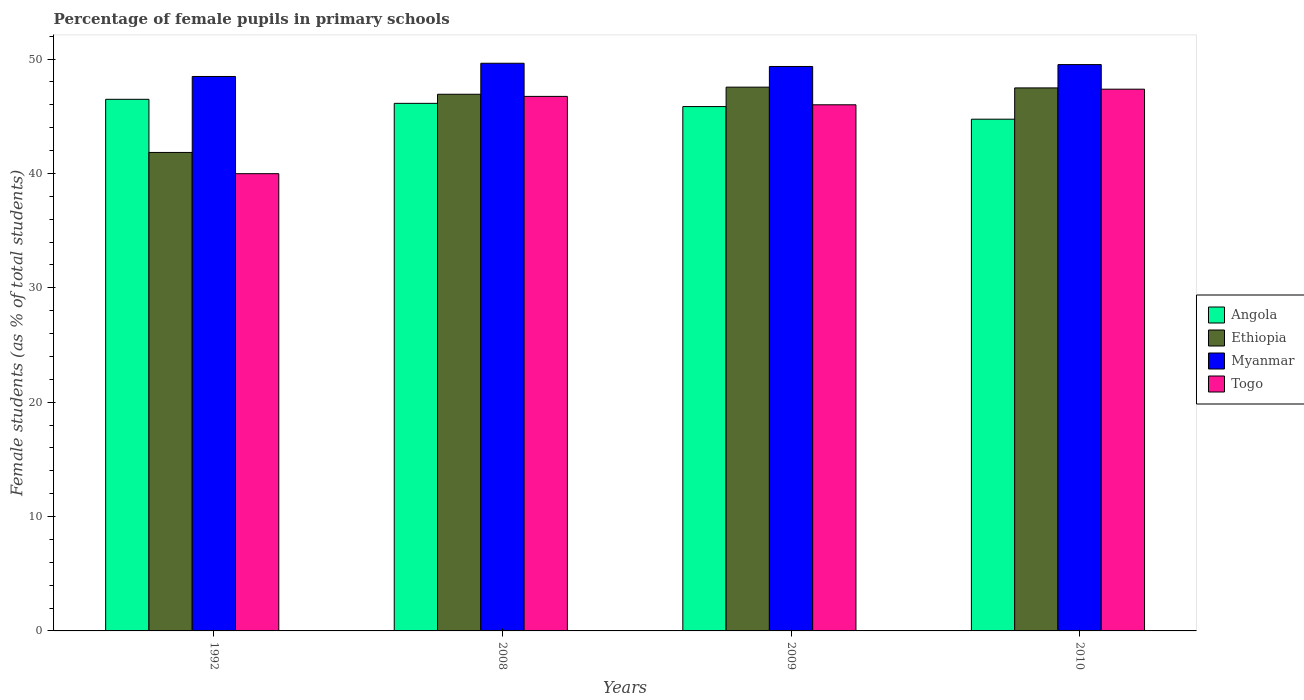What is the percentage of female pupils in primary schools in Ethiopia in 2008?
Offer a very short reply. 46.92. Across all years, what is the maximum percentage of female pupils in primary schools in Angola?
Provide a short and direct response. 46.48. Across all years, what is the minimum percentage of female pupils in primary schools in Myanmar?
Make the answer very short. 48.47. In which year was the percentage of female pupils in primary schools in Myanmar minimum?
Keep it short and to the point. 1992. What is the total percentage of female pupils in primary schools in Ethiopia in the graph?
Your answer should be very brief. 183.76. What is the difference between the percentage of female pupils in primary schools in Togo in 1992 and that in 2009?
Keep it short and to the point. -6.02. What is the difference between the percentage of female pupils in primary schools in Togo in 2010 and the percentage of female pupils in primary schools in Myanmar in 2009?
Keep it short and to the point. -1.98. What is the average percentage of female pupils in primary schools in Togo per year?
Give a very brief answer. 45.02. In the year 1992, what is the difference between the percentage of female pupils in primary schools in Angola and percentage of female pupils in primary schools in Ethiopia?
Your answer should be very brief. 4.65. In how many years, is the percentage of female pupils in primary schools in Ethiopia greater than 26 %?
Your answer should be very brief. 4. What is the ratio of the percentage of female pupils in primary schools in Myanmar in 1992 to that in 2008?
Your answer should be very brief. 0.98. What is the difference between the highest and the second highest percentage of female pupils in primary schools in Ethiopia?
Your response must be concise. 0.07. What is the difference between the highest and the lowest percentage of female pupils in primary schools in Myanmar?
Provide a short and direct response. 1.16. Is the sum of the percentage of female pupils in primary schools in Ethiopia in 2009 and 2010 greater than the maximum percentage of female pupils in primary schools in Myanmar across all years?
Keep it short and to the point. Yes. What does the 4th bar from the left in 1992 represents?
Your response must be concise. Togo. What does the 1st bar from the right in 2009 represents?
Provide a short and direct response. Togo. Is it the case that in every year, the sum of the percentage of female pupils in primary schools in Togo and percentage of female pupils in primary schools in Myanmar is greater than the percentage of female pupils in primary schools in Ethiopia?
Keep it short and to the point. Yes. What is the difference between two consecutive major ticks on the Y-axis?
Provide a short and direct response. 10. Where does the legend appear in the graph?
Keep it short and to the point. Center right. How many legend labels are there?
Ensure brevity in your answer.  4. What is the title of the graph?
Give a very brief answer. Percentage of female pupils in primary schools. Does "East Asia (all income levels)" appear as one of the legend labels in the graph?
Provide a short and direct response. No. What is the label or title of the Y-axis?
Provide a succinct answer. Female students (as % of total students). What is the Female students (as % of total students) in Angola in 1992?
Keep it short and to the point. 46.48. What is the Female students (as % of total students) in Ethiopia in 1992?
Offer a very short reply. 41.83. What is the Female students (as % of total students) in Myanmar in 1992?
Offer a terse response. 48.47. What is the Female students (as % of total students) in Togo in 1992?
Provide a short and direct response. 39.97. What is the Female students (as % of total students) of Angola in 2008?
Offer a very short reply. 46.12. What is the Female students (as % of total students) of Ethiopia in 2008?
Offer a very short reply. 46.92. What is the Female students (as % of total students) of Myanmar in 2008?
Keep it short and to the point. 49.63. What is the Female students (as % of total students) of Togo in 2008?
Provide a short and direct response. 46.73. What is the Female students (as % of total students) of Angola in 2009?
Your answer should be very brief. 45.84. What is the Female students (as % of total students) of Ethiopia in 2009?
Your answer should be compact. 47.54. What is the Female students (as % of total students) of Myanmar in 2009?
Your answer should be very brief. 49.35. What is the Female students (as % of total students) of Togo in 2009?
Offer a very short reply. 46. What is the Female students (as % of total students) in Angola in 2010?
Make the answer very short. 44.74. What is the Female students (as % of total students) of Ethiopia in 2010?
Your answer should be compact. 47.47. What is the Female students (as % of total students) in Myanmar in 2010?
Offer a very short reply. 49.51. What is the Female students (as % of total students) of Togo in 2010?
Provide a succinct answer. 47.36. Across all years, what is the maximum Female students (as % of total students) in Angola?
Provide a succinct answer. 46.48. Across all years, what is the maximum Female students (as % of total students) of Ethiopia?
Offer a very short reply. 47.54. Across all years, what is the maximum Female students (as % of total students) of Myanmar?
Your answer should be very brief. 49.63. Across all years, what is the maximum Female students (as % of total students) of Togo?
Give a very brief answer. 47.36. Across all years, what is the minimum Female students (as % of total students) in Angola?
Ensure brevity in your answer.  44.74. Across all years, what is the minimum Female students (as % of total students) in Ethiopia?
Provide a succinct answer. 41.83. Across all years, what is the minimum Female students (as % of total students) of Myanmar?
Ensure brevity in your answer.  48.47. Across all years, what is the minimum Female students (as % of total students) of Togo?
Your answer should be compact. 39.97. What is the total Female students (as % of total students) in Angola in the graph?
Offer a very short reply. 183.18. What is the total Female students (as % of total students) in Ethiopia in the graph?
Provide a short and direct response. 183.76. What is the total Female students (as % of total students) in Myanmar in the graph?
Your response must be concise. 196.96. What is the total Female students (as % of total students) of Togo in the graph?
Your answer should be very brief. 180.07. What is the difference between the Female students (as % of total students) of Angola in 1992 and that in 2008?
Keep it short and to the point. 0.35. What is the difference between the Female students (as % of total students) of Ethiopia in 1992 and that in 2008?
Provide a short and direct response. -5.09. What is the difference between the Female students (as % of total students) in Myanmar in 1992 and that in 2008?
Your answer should be compact. -1.16. What is the difference between the Female students (as % of total students) of Togo in 1992 and that in 2008?
Offer a very short reply. -6.76. What is the difference between the Female students (as % of total students) of Angola in 1992 and that in 2009?
Ensure brevity in your answer.  0.63. What is the difference between the Female students (as % of total students) in Ethiopia in 1992 and that in 2009?
Provide a short and direct response. -5.71. What is the difference between the Female students (as % of total students) in Myanmar in 1992 and that in 2009?
Provide a short and direct response. -0.87. What is the difference between the Female students (as % of total students) of Togo in 1992 and that in 2009?
Your answer should be compact. -6.02. What is the difference between the Female students (as % of total students) in Angola in 1992 and that in 2010?
Give a very brief answer. 1.74. What is the difference between the Female students (as % of total students) in Ethiopia in 1992 and that in 2010?
Make the answer very short. -5.64. What is the difference between the Female students (as % of total students) of Myanmar in 1992 and that in 2010?
Make the answer very short. -1.04. What is the difference between the Female students (as % of total students) of Togo in 1992 and that in 2010?
Offer a very short reply. -7.39. What is the difference between the Female students (as % of total students) of Angola in 2008 and that in 2009?
Make the answer very short. 0.28. What is the difference between the Female students (as % of total students) of Ethiopia in 2008 and that in 2009?
Keep it short and to the point. -0.62. What is the difference between the Female students (as % of total students) in Myanmar in 2008 and that in 2009?
Keep it short and to the point. 0.28. What is the difference between the Female students (as % of total students) of Togo in 2008 and that in 2009?
Keep it short and to the point. 0.73. What is the difference between the Female students (as % of total students) in Angola in 2008 and that in 2010?
Make the answer very short. 1.39. What is the difference between the Female students (as % of total students) of Ethiopia in 2008 and that in 2010?
Provide a short and direct response. -0.55. What is the difference between the Female students (as % of total students) in Myanmar in 2008 and that in 2010?
Offer a terse response. 0.12. What is the difference between the Female students (as % of total students) in Togo in 2008 and that in 2010?
Offer a very short reply. -0.63. What is the difference between the Female students (as % of total students) in Angola in 2009 and that in 2010?
Provide a succinct answer. 1.1. What is the difference between the Female students (as % of total students) in Ethiopia in 2009 and that in 2010?
Provide a succinct answer. 0.07. What is the difference between the Female students (as % of total students) of Myanmar in 2009 and that in 2010?
Provide a succinct answer. -0.17. What is the difference between the Female students (as % of total students) of Togo in 2009 and that in 2010?
Offer a terse response. -1.36. What is the difference between the Female students (as % of total students) of Angola in 1992 and the Female students (as % of total students) of Ethiopia in 2008?
Ensure brevity in your answer.  -0.44. What is the difference between the Female students (as % of total students) in Angola in 1992 and the Female students (as % of total students) in Myanmar in 2008?
Your response must be concise. -3.15. What is the difference between the Female students (as % of total students) of Angola in 1992 and the Female students (as % of total students) of Togo in 2008?
Keep it short and to the point. -0.25. What is the difference between the Female students (as % of total students) of Ethiopia in 1992 and the Female students (as % of total students) of Myanmar in 2008?
Give a very brief answer. -7.8. What is the difference between the Female students (as % of total students) of Ethiopia in 1992 and the Female students (as % of total students) of Togo in 2008?
Your answer should be compact. -4.9. What is the difference between the Female students (as % of total students) of Myanmar in 1992 and the Female students (as % of total students) of Togo in 2008?
Keep it short and to the point. 1.74. What is the difference between the Female students (as % of total students) of Angola in 1992 and the Female students (as % of total students) of Ethiopia in 2009?
Your response must be concise. -1.06. What is the difference between the Female students (as % of total students) of Angola in 1992 and the Female students (as % of total students) of Myanmar in 2009?
Ensure brevity in your answer.  -2.87. What is the difference between the Female students (as % of total students) in Angola in 1992 and the Female students (as % of total students) in Togo in 2009?
Keep it short and to the point. 0.48. What is the difference between the Female students (as % of total students) in Ethiopia in 1992 and the Female students (as % of total students) in Myanmar in 2009?
Keep it short and to the point. -7.52. What is the difference between the Female students (as % of total students) of Ethiopia in 1992 and the Female students (as % of total students) of Togo in 2009?
Give a very brief answer. -4.17. What is the difference between the Female students (as % of total students) of Myanmar in 1992 and the Female students (as % of total students) of Togo in 2009?
Your answer should be compact. 2.47. What is the difference between the Female students (as % of total students) of Angola in 1992 and the Female students (as % of total students) of Ethiopia in 2010?
Provide a succinct answer. -1. What is the difference between the Female students (as % of total students) of Angola in 1992 and the Female students (as % of total students) of Myanmar in 2010?
Offer a terse response. -3.04. What is the difference between the Female students (as % of total students) in Angola in 1992 and the Female students (as % of total students) in Togo in 2010?
Your answer should be compact. -0.89. What is the difference between the Female students (as % of total students) of Ethiopia in 1992 and the Female students (as % of total students) of Myanmar in 2010?
Give a very brief answer. -7.68. What is the difference between the Female students (as % of total students) of Ethiopia in 1992 and the Female students (as % of total students) of Togo in 2010?
Keep it short and to the point. -5.53. What is the difference between the Female students (as % of total students) of Myanmar in 1992 and the Female students (as % of total students) of Togo in 2010?
Provide a succinct answer. 1.11. What is the difference between the Female students (as % of total students) of Angola in 2008 and the Female students (as % of total students) of Ethiopia in 2009?
Keep it short and to the point. -1.42. What is the difference between the Female students (as % of total students) of Angola in 2008 and the Female students (as % of total students) of Myanmar in 2009?
Offer a very short reply. -3.22. What is the difference between the Female students (as % of total students) in Angola in 2008 and the Female students (as % of total students) in Togo in 2009?
Offer a terse response. 0.13. What is the difference between the Female students (as % of total students) of Ethiopia in 2008 and the Female students (as % of total students) of Myanmar in 2009?
Your response must be concise. -2.43. What is the difference between the Female students (as % of total students) of Ethiopia in 2008 and the Female students (as % of total students) of Togo in 2009?
Offer a terse response. 0.92. What is the difference between the Female students (as % of total students) of Myanmar in 2008 and the Female students (as % of total students) of Togo in 2009?
Your response must be concise. 3.63. What is the difference between the Female students (as % of total students) of Angola in 2008 and the Female students (as % of total students) of Ethiopia in 2010?
Make the answer very short. -1.35. What is the difference between the Female students (as % of total students) of Angola in 2008 and the Female students (as % of total students) of Myanmar in 2010?
Ensure brevity in your answer.  -3.39. What is the difference between the Female students (as % of total students) of Angola in 2008 and the Female students (as % of total students) of Togo in 2010?
Offer a terse response. -1.24. What is the difference between the Female students (as % of total students) of Ethiopia in 2008 and the Female students (as % of total students) of Myanmar in 2010?
Provide a succinct answer. -2.59. What is the difference between the Female students (as % of total students) in Ethiopia in 2008 and the Female students (as % of total students) in Togo in 2010?
Keep it short and to the point. -0.44. What is the difference between the Female students (as % of total students) of Myanmar in 2008 and the Female students (as % of total students) of Togo in 2010?
Offer a terse response. 2.27. What is the difference between the Female students (as % of total students) in Angola in 2009 and the Female students (as % of total students) in Ethiopia in 2010?
Give a very brief answer. -1.63. What is the difference between the Female students (as % of total students) in Angola in 2009 and the Female students (as % of total students) in Myanmar in 2010?
Ensure brevity in your answer.  -3.67. What is the difference between the Female students (as % of total students) of Angola in 2009 and the Female students (as % of total students) of Togo in 2010?
Offer a very short reply. -1.52. What is the difference between the Female students (as % of total students) in Ethiopia in 2009 and the Female students (as % of total students) in Myanmar in 2010?
Offer a terse response. -1.97. What is the difference between the Female students (as % of total students) of Ethiopia in 2009 and the Female students (as % of total students) of Togo in 2010?
Your answer should be very brief. 0.18. What is the difference between the Female students (as % of total students) in Myanmar in 2009 and the Female students (as % of total students) in Togo in 2010?
Provide a succinct answer. 1.98. What is the average Female students (as % of total students) of Angola per year?
Give a very brief answer. 45.8. What is the average Female students (as % of total students) of Ethiopia per year?
Keep it short and to the point. 45.94. What is the average Female students (as % of total students) of Myanmar per year?
Give a very brief answer. 49.24. What is the average Female students (as % of total students) of Togo per year?
Provide a short and direct response. 45.02. In the year 1992, what is the difference between the Female students (as % of total students) of Angola and Female students (as % of total students) of Ethiopia?
Your answer should be compact. 4.65. In the year 1992, what is the difference between the Female students (as % of total students) of Angola and Female students (as % of total students) of Myanmar?
Your answer should be very brief. -2. In the year 1992, what is the difference between the Female students (as % of total students) in Angola and Female students (as % of total students) in Togo?
Your answer should be compact. 6.5. In the year 1992, what is the difference between the Female students (as % of total students) of Ethiopia and Female students (as % of total students) of Myanmar?
Offer a terse response. -6.64. In the year 1992, what is the difference between the Female students (as % of total students) in Ethiopia and Female students (as % of total students) in Togo?
Give a very brief answer. 1.86. In the year 1992, what is the difference between the Female students (as % of total students) of Myanmar and Female students (as % of total students) of Togo?
Offer a terse response. 8.5. In the year 2008, what is the difference between the Female students (as % of total students) of Angola and Female students (as % of total students) of Ethiopia?
Your answer should be very brief. -0.8. In the year 2008, what is the difference between the Female students (as % of total students) in Angola and Female students (as % of total students) in Myanmar?
Provide a succinct answer. -3.51. In the year 2008, what is the difference between the Female students (as % of total students) of Angola and Female students (as % of total students) of Togo?
Your answer should be compact. -0.61. In the year 2008, what is the difference between the Female students (as % of total students) in Ethiopia and Female students (as % of total students) in Myanmar?
Ensure brevity in your answer.  -2.71. In the year 2008, what is the difference between the Female students (as % of total students) of Ethiopia and Female students (as % of total students) of Togo?
Make the answer very short. 0.19. In the year 2008, what is the difference between the Female students (as % of total students) of Myanmar and Female students (as % of total students) of Togo?
Provide a succinct answer. 2.9. In the year 2009, what is the difference between the Female students (as % of total students) in Angola and Female students (as % of total students) in Ethiopia?
Your response must be concise. -1.7. In the year 2009, what is the difference between the Female students (as % of total students) of Angola and Female students (as % of total students) of Myanmar?
Ensure brevity in your answer.  -3.5. In the year 2009, what is the difference between the Female students (as % of total students) in Angola and Female students (as % of total students) in Togo?
Offer a very short reply. -0.16. In the year 2009, what is the difference between the Female students (as % of total students) in Ethiopia and Female students (as % of total students) in Myanmar?
Provide a short and direct response. -1.81. In the year 2009, what is the difference between the Female students (as % of total students) in Ethiopia and Female students (as % of total students) in Togo?
Keep it short and to the point. 1.54. In the year 2009, what is the difference between the Female students (as % of total students) in Myanmar and Female students (as % of total students) in Togo?
Your answer should be compact. 3.35. In the year 2010, what is the difference between the Female students (as % of total students) of Angola and Female students (as % of total students) of Ethiopia?
Offer a terse response. -2.73. In the year 2010, what is the difference between the Female students (as % of total students) in Angola and Female students (as % of total students) in Myanmar?
Ensure brevity in your answer.  -4.78. In the year 2010, what is the difference between the Female students (as % of total students) in Angola and Female students (as % of total students) in Togo?
Your response must be concise. -2.62. In the year 2010, what is the difference between the Female students (as % of total students) of Ethiopia and Female students (as % of total students) of Myanmar?
Offer a very short reply. -2.04. In the year 2010, what is the difference between the Female students (as % of total students) of Ethiopia and Female students (as % of total students) of Togo?
Offer a terse response. 0.11. In the year 2010, what is the difference between the Female students (as % of total students) of Myanmar and Female students (as % of total students) of Togo?
Your answer should be compact. 2.15. What is the ratio of the Female students (as % of total students) in Angola in 1992 to that in 2008?
Provide a succinct answer. 1.01. What is the ratio of the Female students (as % of total students) of Ethiopia in 1992 to that in 2008?
Your answer should be compact. 0.89. What is the ratio of the Female students (as % of total students) of Myanmar in 1992 to that in 2008?
Keep it short and to the point. 0.98. What is the ratio of the Female students (as % of total students) of Togo in 1992 to that in 2008?
Make the answer very short. 0.86. What is the ratio of the Female students (as % of total students) of Angola in 1992 to that in 2009?
Provide a succinct answer. 1.01. What is the ratio of the Female students (as % of total students) in Ethiopia in 1992 to that in 2009?
Offer a very short reply. 0.88. What is the ratio of the Female students (as % of total students) of Myanmar in 1992 to that in 2009?
Give a very brief answer. 0.98. What is the ratio of the Female students (as % of total students) of Togo in 1992 to that in 2009?
Keep it short and to the point. 0.87. What is the ratio of the Female students (as % of total students) of Angola in 1992 to that in 2010?
Provide a succinct answer. 1.04. What is the ratio of the Female students (as % of total students) in Ethiopia in 1992 to that in 2010?
Your response must be concise. 0.88. What is the ratio of the Female students (as % of total students) of Togo in 1992 to that in 2010?
Make the answer very short. 0.84. What is the ratio of the Female students (as % of total students) of Ethiopia in 2008 to that in 2009?
Your response must be concise. 0.99. What is the ratio of the Female students (as % of total students) in Myanmar in 2008 to that in 2009?
Your response must be concise. 1.01. What is the ratio of the Female students (as % of total students) of Togo in 2008 to that in 2009?
Ensure brevity in your answer.  1.02. What is the ratio of the Female students (as % of total students) in Angola in 2008 to that in 2010?
Give a very brief answer. 1.03. What is the ratio of the Female students (as % of total students) of Ethiopia in 2008 to that in 2010?
Make the answer very short. 0.99. What is the ratio of the Female students (as % of total students) of Myanmar in 2008 to that in 2010?
Keep it short and to the point. 1. What is the ratio of the Female students (as % of total students) of Togo in 2008 to that in 2010?
Your answer should be very brief. 0.99. What is the ratio of the Female students (as % of total students) of Angola in 2009 to that in 2010?
Offer a terse response. 1.02. What is the ratio of the Female students (as % of total students) of Togo in 2009 to that in 2010?
Provide a short and direct response. 0.97. What is the difference between the highest and the second highest Female students (as % of total students) in Angola?
Ensure brevity in your answer.  0.35. What is the difference between the highest and the second highest Female students (as % of total students) in Ethiopia?
Provide a short and direct response. 0.07. What is the difference between the highest and the second highest Female students (as % of total students) of Myanmar?
Give a very brief answer. 0.12. What is the difference between the highest and the second highest Female students (as % of total students) in Togo?
Keep it short and to the point. 0.63. What is the difference between the highest and the lowest Female students (as % of total students) in Angola?
Give a very brief answer. 1.74. What is the difference between the highest and the lowest Female students (as % of total students) of Ethiopia?
Ensure brevity in your answer.  5.71. What is the difference between the highest and the lowest Female students (as % of total students) of Myanmar?
Offer a terse response. 1.16. What is the difference between the highest and the lowest Female students (as % of total students) of Togo?
Make the answer very short. 7.39. 